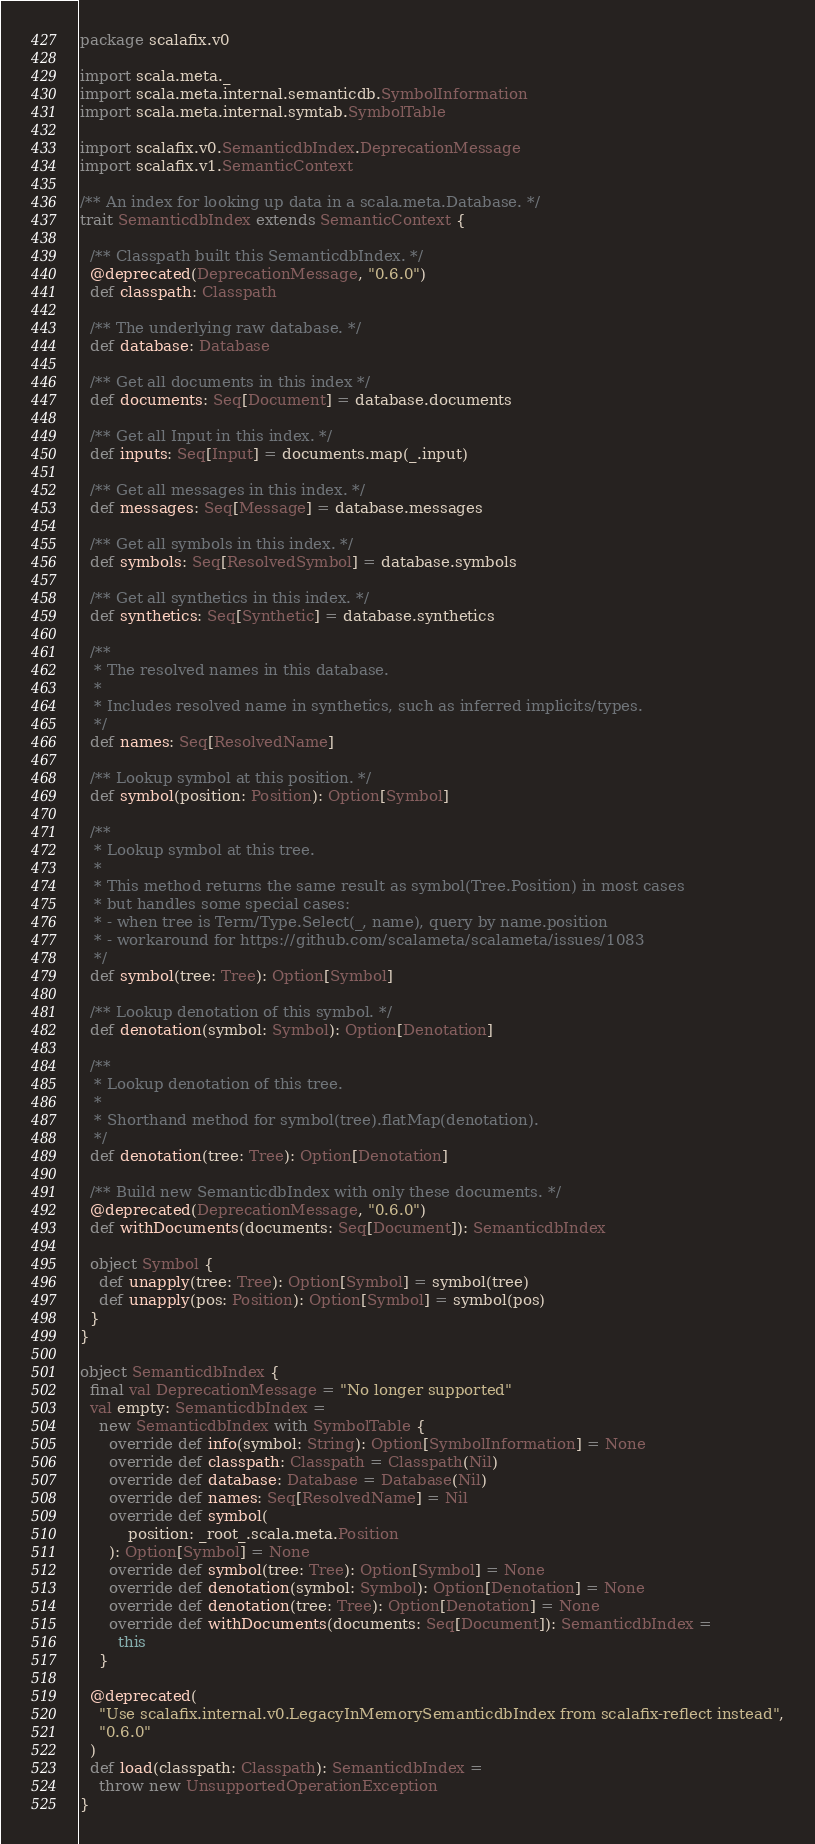<code> <loc_0><loc_0><loc_500><loc_500><_Scala_>package scalafix.v0

import scala.meta._
import scala.meta.internal.semanticdb.SymbolInformation
import scala.meta.internal.symtab.SymbolTable

import scalafix.v0.SemanticdbIndex.DeprecationMessage
import scalafix.v1.SemanticContext

/** An index for looking up data in a scala.meta.Database. */
trait SemanticdbIndex extends SemanticContext {

  /** Classpath built this SemanticdbIndex. */
  @deprecated(DeprecationMessage, "0.6.0")
  def classpath: Classpath

  /** The underlying raw database. */
  def database: Database

  /** Get all documents in this index */
  def documents: Seq[Document] = database.documents

  /** Get all Input in this index. */
  def inputs: Seq[Input] = documents.map(_.input)

  /** Get all messages in this index. */
  def messages: Seq[Message] = database.messages

  /** Get all symbols in this index. */
  def symbols: Seq[ResolvedSymbol] = database.symbols

  /** Get all synthetics in this index. */
  def synthetics: Seq[Synthetic] = database.synthetics

  /**
   * The resolved names in this database.
   *
   * Includes resolved name in synthetics, such as inferred implicits/types.
   */
  def names: Seq[ResolvedName]

  /** Lookup symbol at this position. */
  def symbol(position: Position): Option[Symbol]

  /**
   * Lookup symbol at this tree.
   *
   * This method returns the same result as symbol(Tree.Position) in most cases
   * but handles some special cases:
   * - when tree is Term/Type.Select(_, name), query by name.position
   * - workaround for https://github.com/scalameta/scalameta/issues/1083
   */
  def symbol(tree: Tree): Option[Symbol]

  /** Lookup denotation of this symbol. */
  def denotation(symbol: Symbol): Option[Denotation]

  /**
   * Lookup denotation of this tree.
   *
   * Shorthand method for symbol(tree).flatMap(denotation).
   */
  def denotation(tree: Tree): Option[Denotation]

  /** Build new SemanticdbIndex with only these documents. */
  @deprecated(DeprecationMessage, "0.6.0")
  def withDocuments(documents: Seq[Document]): SemanticdbIndex

  object Symbol {
    def unapply(tree: Tree): Option[Symbol] = symbol(tree)
    def unapply(pos: Position): Option[Symbol] = symbol(pos)
  }
}

object SemanticdbIndex {
  final val DeprecationMessage = "No longer supported"
  val empty: SemanticdbIndex =
    new SemanticdbIndex with SymbolTable {
      override def info(symbol: String): Option[SymbolInformation] = None
      override def classpath: Classpath = Classpath(Nil)
      override def database: Database = Database(Nil)
      override def names: Seq[ResolvedName] = Nil
      override def symbol(
          position: _root_.scala.meta.Position
      ): Option[Symbol] = None
      override def symbol(tree: Tree): Option[Symbol] = None
      override def denotation(symbol: Symbol): Option[Denotation] = None
      override def denotation(tree: Tree): Option[Denotation] = None
      override def withDocuments(documents: Seq[Document]): SemanticdbIndex =
        this
    }

  @deprecated(
    "Use scalafix.internal.v0.LegacyInMemorySemanticdbIndex from scalafix-reflect instead",
    "0.6.0"
  )
  def load(classpath: Classpath): SemanticdbIndex =
    throw new UnsupportedOperationException
}
</code> 